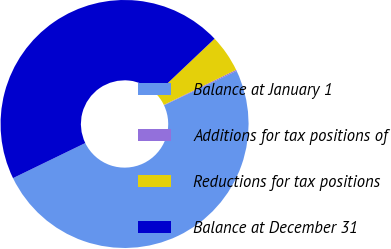Convert chart. <chart><loc_0><loc_0><loc_500><loc_500><pie_chart><fcel>Balance at January 1<fcel>Additions for tax positions of<fcel>Reductions for tax positions<fcel>Balance at December 31<nl><fcel>49.85%<fcel>0.15%<fcel>4.88%<fcel>45.12%<nl></chart> 